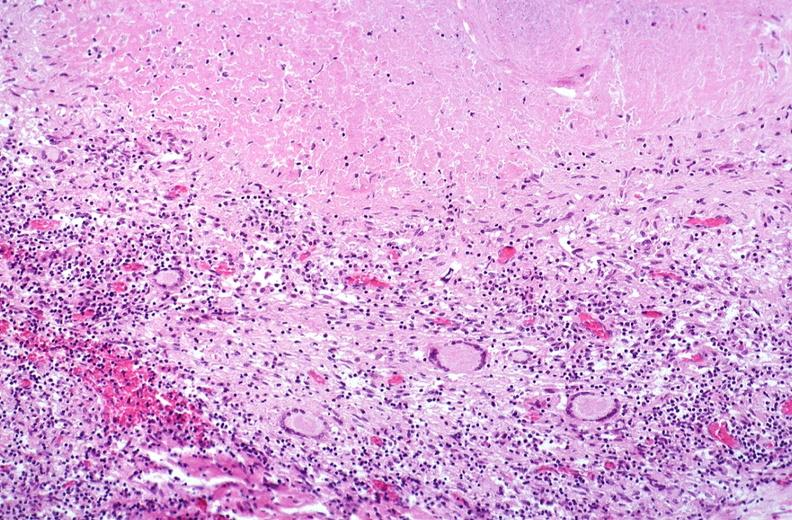where is this?
Answer the question using a single word or phrase. Lung 